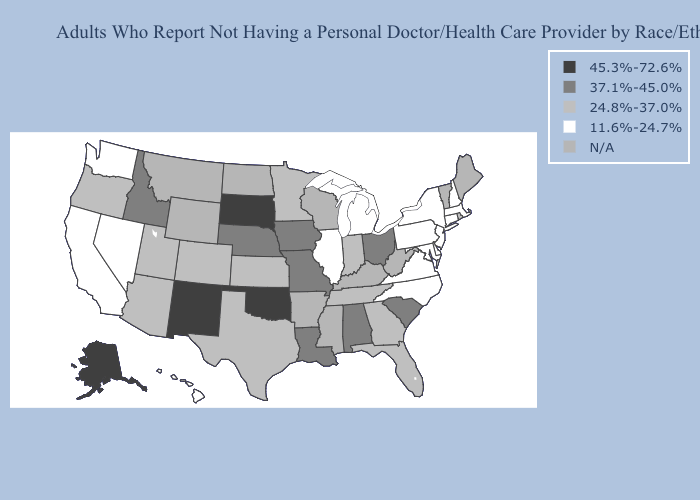What is the value of Alabama?
Concise answer only. 37.1%-45.0%. Which states hav the highest value in the Northeast?
Keep it brief. Rhode Island. Name the states that have a value in the range 24.8%-37.0%?
Short answer required. Arizona, Colorado, Florida, Georgia, Indiana, Kansas, Minnesota, Oregon, Rhode Island, Tennessee, Texas, Utah. Name the states that have a value in the range 37.1%-45.0%?
Write a very short answer. Alabama, Idaho, Iowa, Louisiana, Missouri, Nebraska, Ohio, South Carolina. What is the lowest value in the Northeast?
Quick response, please. 11.6%-24.7%. Does Georgia have the lowest value in the USA?
Quick response, please. No. Does Louisiana have the lowest value in the USA?
Be succinct. No. Name the states that have a value in the range 37.1%-45.0%?
Give a very brief answer. Alabama, Idaho, Iowa, Louisiana, Missouri, Nebraska, Ohio, South Carolina. Does Missouri have the lowest value in the MidWest?
Keep it brief. No. What is the value of Mississippi?
Quick response, please. N/A. Which states hav the highest value in the West?
Answer briefly. Alaska, New Mexico. Is the legend a continuous bar?
Answer briefly. No. What is the highest value in the USA?
Give a very brief answer. 45.3%-72.6%. What is the value of Oregon?
Quick response, please. 24.8%-37.0%. 